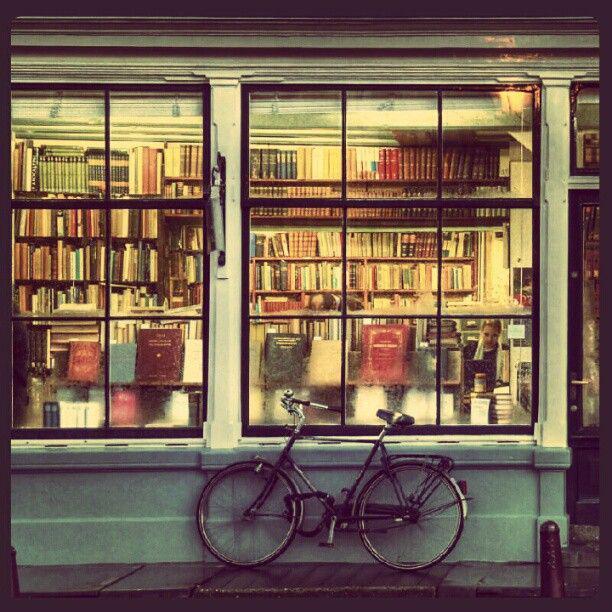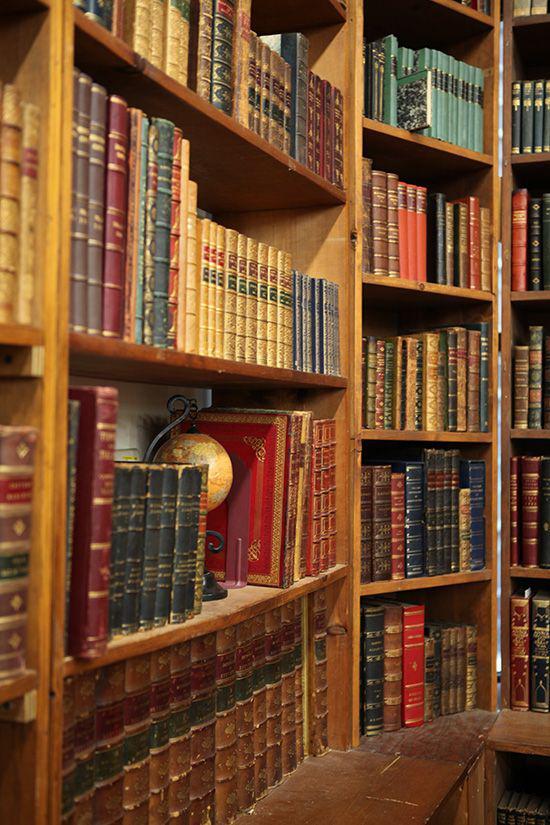The first image is the image on the left, the second image is the image on the right. For the images displayed, is the sentence "One of the images shows the outside of a bookstore." factually correct? Answer yes or no. Yes. The first image is the image on the left, the second image is the image on the right. Considering the images on both sides, is "One image shows the exterior of a book shop." valid? Answer yes or no. Yes. 